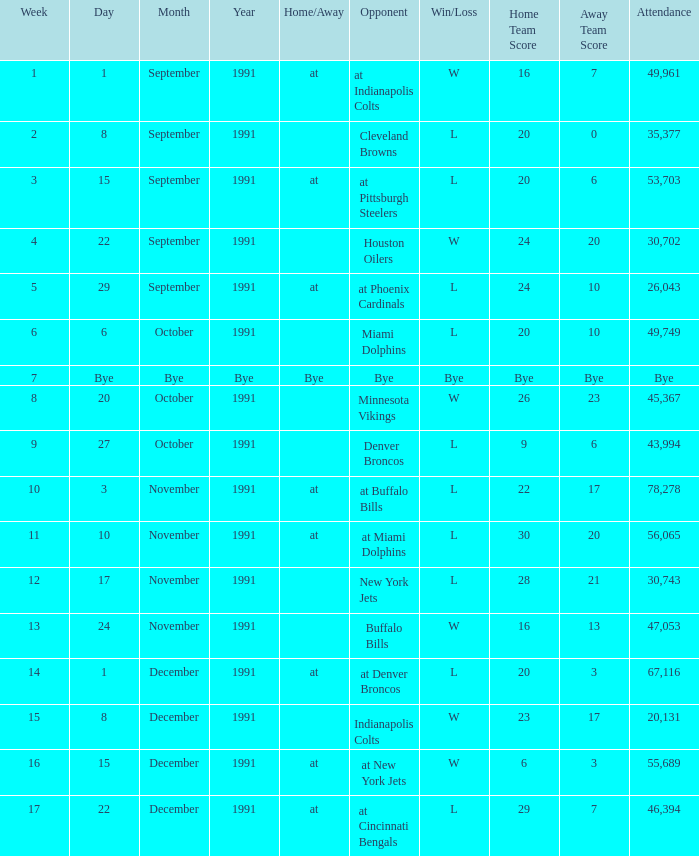What was the result of the game after Week 13 on December 8, 1991? W 23–17. 